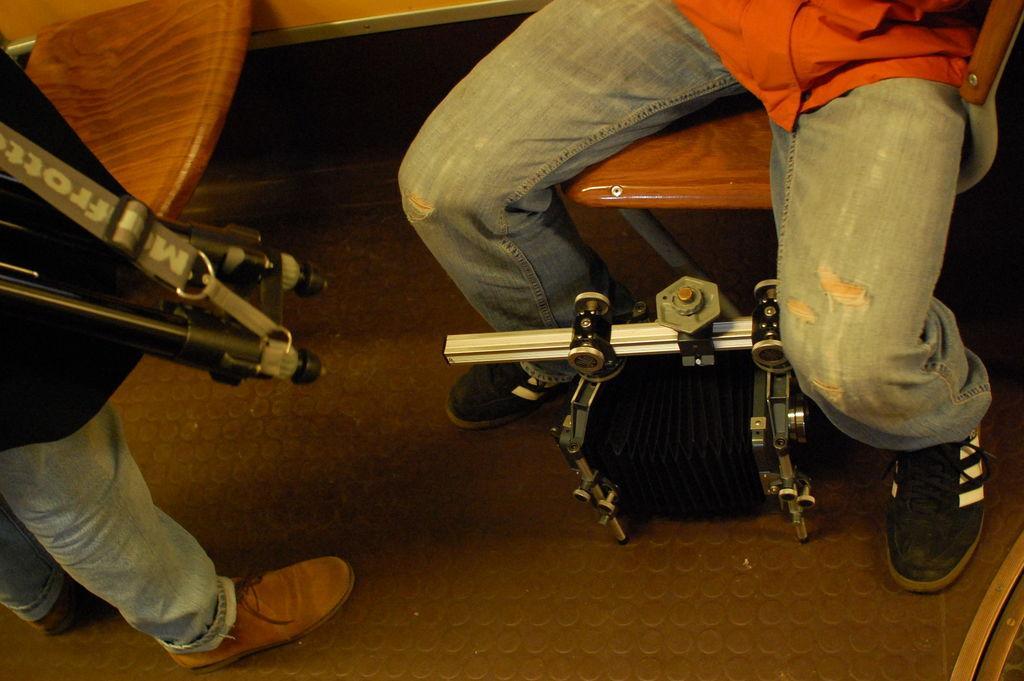Describe this image in one or two sentences. In this picture there is a person sitting on the chair and there is a person standing. At the bottom there is a machine. At the back there is a table. At the bottom there is a floor. 